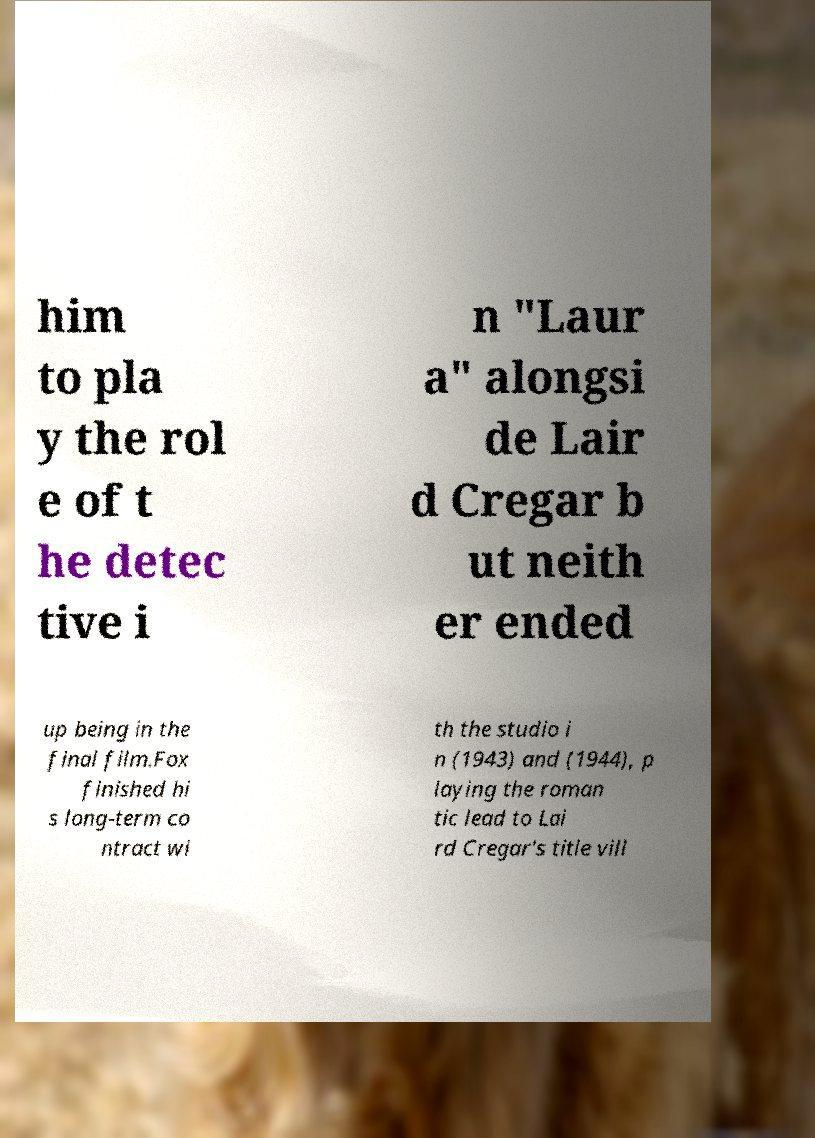For documentation purposes, I need the text within this image transcribed. Could you provide that? him to pla y the rol e of t he detec tive i n "Laur a" alongsi de Lair d Cregar b ut neith er ended up being in the final film.Fox finished hi s long-term co ntract wi th the studio i n (1943) and (1944), p laying the roman tic lead to Lai rd Cregar's title vill 